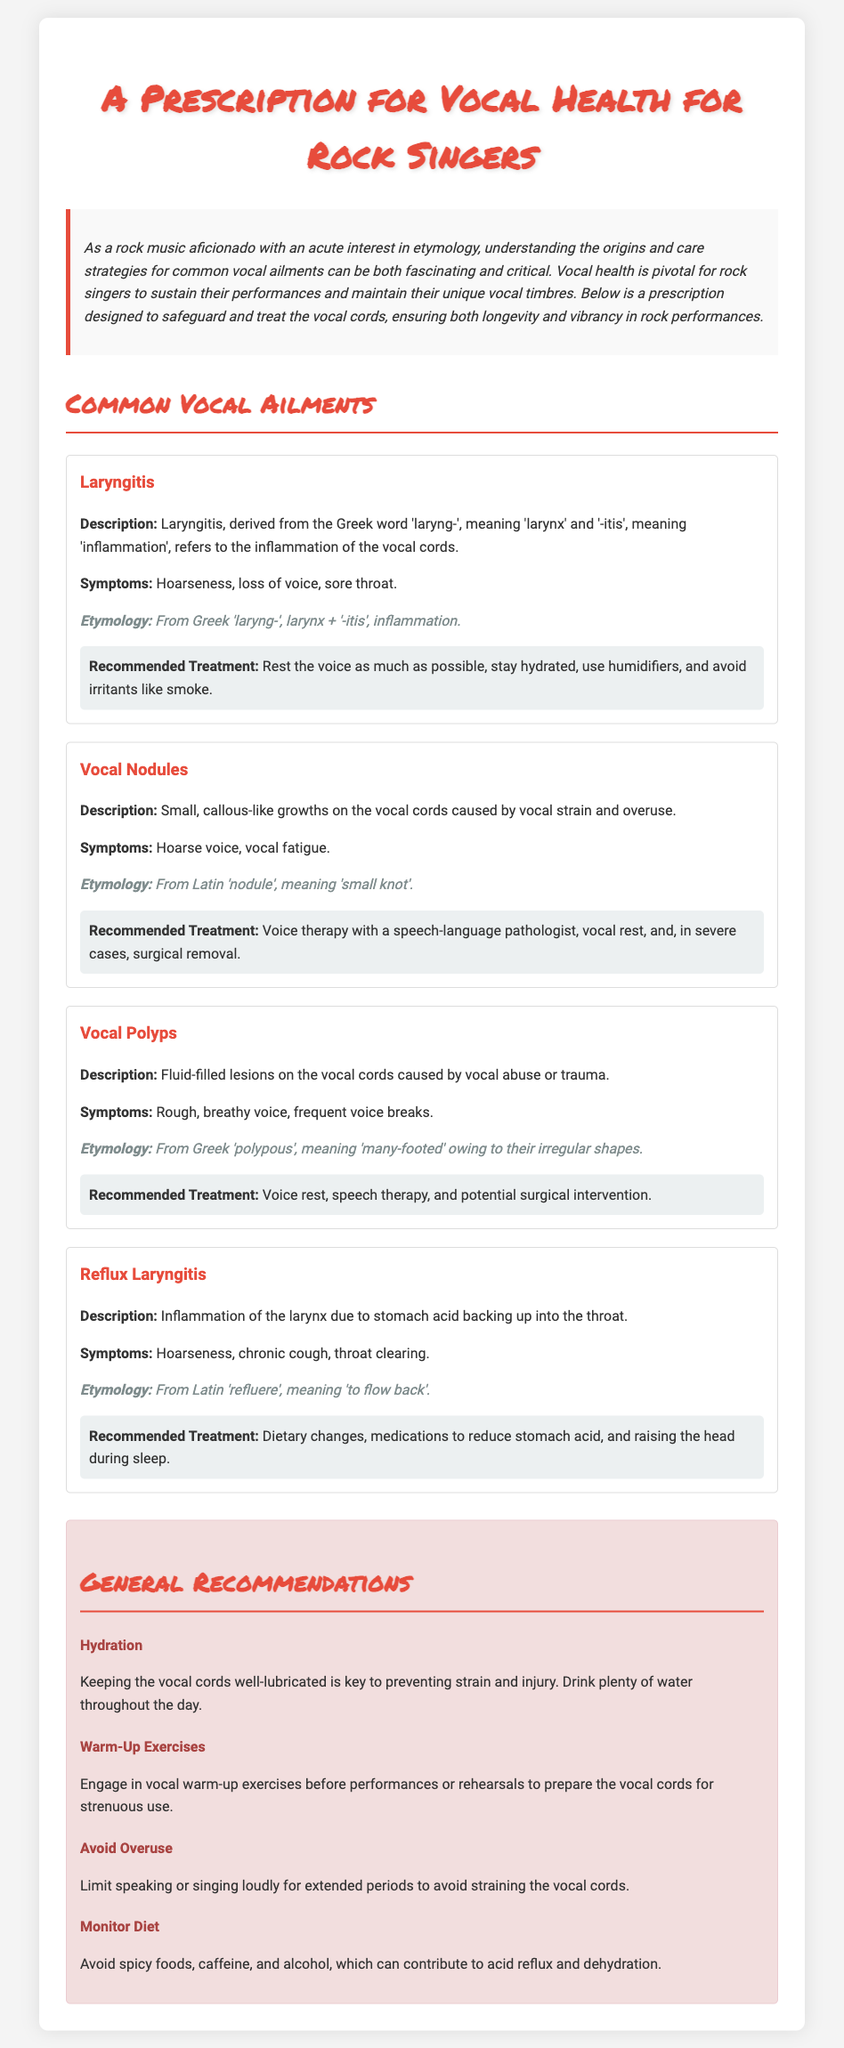What is the title of the document? The title appears prominently at the top of the document, stating the full prescription content.
Answer: A Prescription for Vocal Health for Rock Singers What is the main focus of the document? The introduction clarifies that the focus is on vocal health for rock singers, particularly in preserving vocal quality.
Answer: Vocal health What is the etymology of Laryngitis? The document provides a specific breakdown of the word's origin and meaning.
Answer: From Greek 'laryng-', larynx + '-itis', inflammation What is a common symptom of Vocal Nodules? Symptoms for each ailment are listed under their respective sections, including notable effects on the voice.
Answer: Hoarse voice What recommended treatment is suggested for Reflux Laryngitis? Each ailment includes a section on recommended treatments, detailing various approaches for recovery.
Answer: Dietary changes How should singers prepare their vocal cords before performances? The document includes general recommendations that emphasize preparation and care techniques.
Answer: Warm-Up Exercises What should be avoided to help maintain vocal health? The recommendations section lists specific items and behaviors that could be detrimental to vocal cords.
Answer: Spicy foods How does the document describe Vocal Polyps? The description of each ailment is provided, outlining its nature and causes.
Answer: Fluid-filled lesions What is a key recommendation for hydration? The document specifically mentions the importance of hydration in the recommendations section.
Answer: Drink plenty of water throughout the day 